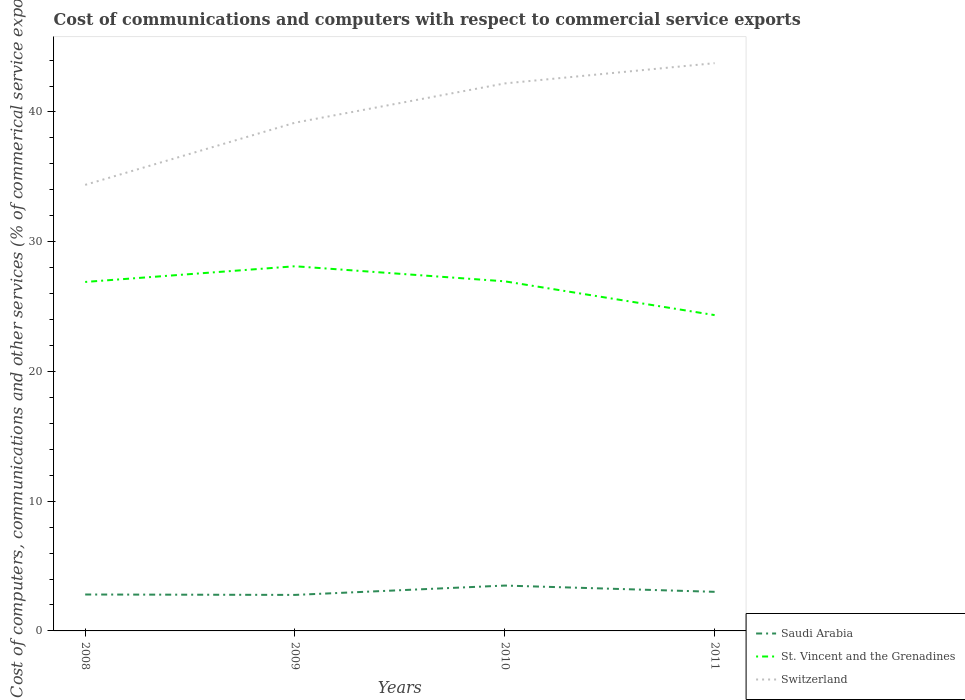How many different coloured lines are there?
Make the answer very short. 3. Does the line corresponding to St. Vincent and the Grenadines intersect with the line corresponding to Switzerland?
Ensure brevity in your answer.  No. Across all years, what is the maximum cost of communications and computers in St. Vincent and the Grenadines?
Your answer should be compact. 24.34. In which year was the cost of communications and computers in Switzerland maximum?
Your response must be concise. 2008. What is the total cost of communications and computers in St. Vincent and the Grenadines in the graph?
Offer a terse response. 3.77. What is the difference between the highest and the second highest cost of communications and computers in St. Vincent and the Grenadines?
Make the answer very short. 3.77. How many years are there in the graph?
Your answer should be very brief. 4. What is the difference between two consecutive major ticks on the Y-axis?
Your response must be concise. 10. Does the graph contain any zero values?
Provide a succinct answer. No. Where does the legend appear in the graph?
Keep it short and to the point. Bottom right. How many legend labels are there?
Your answer should be compact. 3. How are the legend labels stacked?
Provide a short and direct response. Vertical. What is the title of the graph?
Offer a terse response. Cost of communications and computers with respect to commercial service exports. Does "Mongolia" appear as one of the legend labels in the graph?
Your response must be concise. No. What is the label or title of the Y-axis?
Provide a short and direct response. Cost of computers, communications and other services (% of commerical service exports). What is the Cost of computers, communications and other services (% of commerical service exports) in Saudi Arabia in 2008?
Make the answer very short. 2.81. What is the Cost of computers, communications and other services (% of commerical service exports) of St. Vincent and the Grenadines in 2008?
Your answer should be very brief. 26.9. What is the Cost of computers, communications and other services (% of commerical service exports) in Switzerland in 2008?
Make the answer very short. 34.38. What is the Cost of computers, communications and other services (% of commerical service exports) in Saudi Arabia in 2009?
Your answer should be compact. 2.78. What is the Cost of computers, communications and other services (% of commerical service exports) of St. Vincent and the Grenadines in 2009?
Ensure brevity in your answer.  28.11. What is the Cost of computers, communications and other services (% of commerical service exports) in Switzerland in 2009?
Ensure brevity in your answer.  39.17. What is the Cost of computers, communications and other services (% of commerical service exports) of Saudi Arabia in 2010?
Ensure brevity in your answer.  3.5. What is the Cost of computers, communications and other services (% of commerical service exports) in St. Vincent and the Grenadines in 2010?
Ensure brevity in your answer.  26.95. What is the Cost of computers, communications and other services (% of commerical service exports) of Switzerland in 2010?
Provide a short and direct response. 42.2. What is the Cost of computers, communications and other services (% of commerical service exports) of Saudi Arabia in 2011?
Provide a succinct answer. 3.01. What is the Cost of computers, communications and other services (% of commerical service exports) in St. Vincent and the Grenadines in 2011?
Your response must be concise. 24.34. What is the Cost of computers, communications and other services (% of commerical service exports) in Switzerland in 2011?
Provide a succinct answer. 43.76. Across all years, what is the maximum Cost of computers, communications and other services (% of commerical service exports) of Saudi Arabia?
Offer a terse response. 3.5. Across all years, what is the maximum Cost of computers, communications and other services (% of commerical service exports) of St. Vincent and the Grenadines?
Your answer should be compact. 28.11. Across all years, what is the maximum Cost of computers, communications and other services (% of commerical service exports) of Switzerland?
Offer a terse response. 43.76. Across all years, what is the minimum Cost of computers, communications and other services (% of commerical service exports) in Saudi Arabia?
Provide a succinct answer. 2.78. Across all years, what is the minimum Cost of computers, communications and other services (% of commerical service exports) of St. Vincent and the Grenadines?
Your answer should be very brief. 24.34. Across all years, what is the minimum Cost of computers, communications and other services (% of commerical service exports) of Switzerland?
Ensure brevity in your answer.  34.38. What is the total Cost of computers, communications and other services (% of commerical service exports) in Saudi Arabia in the graph?
Offer a terse response. 12.09. What is the total Cost of computers, communications and other services (% of commerical service exports) of St. Vincent and the Grenadines in the graph?
Ensure brevity in your answer.  106.3. What is the total Cost of computers, communications and other services (% of commerical service exports) of Switzerland in the graph?
Provide a short and direct response. 159.52. What is the difference between the Cost of computers, communications and other services (% of commerical service exports) in Saudi Arabia in 2008 and that in 2009?
Provide a succinct answer. 0.03. What is the difference between the Cost of computers, communications and other services (% of commerical service exports) of St. Vincent and the Grenadines in 2008 and that in 2009?
Your answer should be very brief. -1.21. What is the difference between the Cost of computers, communications and other services (% of commerical service exports) of Switzerland in 2008 and that in 2009?
Offer a terse response. -4.79. What is the difference between the Cost of computers, communications and other services (% of commerical service exports) of Saudi Arabia in 2008 and that in 2010?
Ensure brevity in your answer.  -0.69. What is the difference between the Cost of computers, communications and other services (% of commerical service exports) of St. Vincent and the Grenadines in 2008 and that in 2010?
Keep it short and to the point. -0.05. What is the difference between the Cost of computers, communications and other services (% of commerical service exports) in Switzerland in 2008 and that in 2010?
Your answer should be very brief. -7.82. What is the difference between the Cost of computers, communications and other services (% of commerical service exports) of Saudi Arabia in 2008 and that in 2011?
Offer a very short reply. -0.21. What is the difference between the Cost of computers, communications and other services (% of commerical service exports) in St. Vincent and the Grenadines in 2008 and that in 2011?
Your answer should be very brief. 2.56. What is the difference between the Cost of computers, communications and other services (% of commerical service exports) of Switzerland in 2008 and that in 2011?
Keep it short and to the point. -9.38. What is the difference between the Cost of computers, communications and other services (% of commerical service exports) of Saudi Arabia in 2009 and that in 2010?
Keep it short and to the point. -0.72. What is the difference between the Cost of computers, communications and other services (% of commerical service exports) of St. Vincent and the Grenadines in 2009 and that in 2010?
Make the answer very short. 1.16. What is the difference between the Cost of computers, communications and other services (% of commerical service exports) of Switzerland in 2009 and that in 2010?
Provide a short and direct response. -3.03. What is the difference between the Cost of computers, communications and other services (% of commerical service exports) in Saudi Arabia in 2009 and that in 2011?
Offer a terse response. -0.24. What is the difference between the Cost of computers, communications and other services (% of commerical service exports) of St. Vincent and the Grenadines in 2009 and that in 2011?
Provide a short and direct response. 3.77. What is the difference between the Cost of computers, communications and other services (% of commerical service exports) of Switzerland in 2009 and that in 2011?
Offer a very short reply. -4.59. What is the difference between the Cost of computers, communications and other services (% of commerical service exports) in Saudi Arabia in 2010 and that in 2011?
Give a very brief answer. 0.48. What is the difference between the Cost of computers, communications and other services (% of commerical service exports) in St. Vincent and the Grenadines in 2010 and that in 2011?
Ensure brevity in your answer.  2.6. What is the difference between the Cost of computers, communications and other services (% of commerical service exports) in Switzerland in 2010 and that in 2011?
Offer a terse response. -1.56. What is the difference between the Cost of computers, communications and other services (% of commerical service exports) in Saudi Arabia in 2008 and the Cost of computers, communications and other services (% of commerical service exports) in St. Vincent and the Grenadines in 2009?
Offer a terse response. -25.3. What is the difference between the Cost of computers, communications and other services (% of commerical service exports) of Saudi Arabia in 2008 and the Cost of computers, communications and other services (% of commerical service exports) of Switzerland in 2009?
Make the answer very short. -36.37. What is the difference between the Cost of computers, communications and other services (% of commerical service exports) of St. Vincent and the Grenadines in 2008 and the Cost of computers, communications and other services (% of commerical service exports) of Switzerland in 2009?
Make the answer very short. -12.27. What is the difference between the Cost of computers, communications and other services (% of commerical service exports) of Saudi Arabia in 2008 and the Cost of computers, communications and other services (% of commerical service exports) of St. Vincent and the Grenadines in 2010?
Keep it short and to the point. -24.14. What is the difference between the Cost of computers, communications and other services (% of commerical service exports) of Saudi Arabia in 2008 and the Cost of computers, communications and other services (% of commerical service exports) of Switzerland in 2010?
Give a very brief answer. -39.39. What is the difference between the Cost of computers, communications and other services (% of commerical service exports) in St. Vincent and the Grenadines in 2008 and the Cost of computers, communications and other services (% of commerical service exports) in Switzerland in 2010?
Offer a very short reply. -15.3. What is the difference between the Cost of computers, communications and other services (% of commerical service exports) of Saudi Arabia in 2008 and the Cost of computers, communications and other services (% of commerical service exports) of St. Vincent and the Grenadines in 2011?
Offer a very short reply. -21.54. What is the difference between the Cost of computers, communications and other services (% of commerical service exports) of Saudi Arabia in 2008 and the Cost of computers, communications and other services (% of commerical service exports) of Switzerland in 2011?
Your response must be concise. -40.96. What is the difference between the Cost of computers, communications and other services (% of commerical service exports) of St. Vincent and the Grenadines in 2008 and the Cost of computers, communications and other services (% of commerical service exports) of Switzerland in 2011?
Provide a short and direct response. -16.86. What is the difference between the Cost of computers, communications and other services (% of commerical service exports) of Saudi Arabia in 2009 and the Cost of computers, communications and other services (% of commerical service exports) of St. Vincent and the Grenadines in 2010?
Make the answer very short. -24.17. What is the difference between the Cost of computers, communications and other services (% of commerical service exports) in Saudi Arabia in 2009 and the Cost of computers, communications and other services (% of commerical service exports) in Switzerland in 2010?
Provide a succinct answer. -39.42. What is the difference between the Cost of computers, communications and other services (% of commerical service exports) of St. Vincent and the Grenadines in 2009 and the Cost of computers, communications and other services (% of commerical service exports) of Switzerland in 2010?
Your response must be concise. -14.09. What is the difference between the Cost of computers, communications and other services (% of commerical service exports) in Saudi Arabia in 2009 and the Cost of computers, communications and other services (% of commerical service exports) in St. Vincent and the Grenadines in 2011?
Make the answer very short. -21.57. What is the difference between the Cost of computers, communications and other services (% of commerical service exports) in Saudi Arabia in 2009 and the Cost of computers, communications and other services (% of commerical service exports) in Switzerland in 2011?
Provide a short and direct response. -40.99. What is the difference between the Cost of computers, communications and other services (% of commerical service exports) in St. Vincent and the Grenadines in 2009 and the Cost of computers, communications and other services (% of commerical service exports) in Switzerland in 2011?
Give a very brief answer. -15.65. What is the difference between the Cost of computers, communications and other services (% of commerical service exports) in Saudi Arabia in 2010 and the Cost of computers, communications and other services (% of commerical service exports) in St. Vincent and the Grenadines in 2011?
Keep it short and to the point. -20.85. What is the difference between the Cost of computers, communications and other services (% of commerical service exports) in Saudi Arabia in 2010 and the Cost of computers, communications and other services (% of commerical service exports) in Switzerland in 2011?
Make the answer very short. -40.27. What is the difference between the Cost of computers, communications and other services (% of commerical service exports) in St. Vincent and the Grenadines in 2010 and the Cost of computers, communications and other services (% of commerical service exports) in Switzerland in 2011?
Provide a short and direct response. -16.82. What is the average Cost of computers, communications and other services (% of commerical service exports) of Saudi Arabia per year?
Provide a short and direct response. 3.02. What is the average Cost of computers, communications and other services (% of commerical service exports) in St. Vincent and the Grenadines per year?
Provide a short and direct response. 26.57. What is the average Cost of computers, communications and other services (% of commerical service exports) of Switzerland per year?
Ensure brevity in your answer.  39.88. In the year 2008, what is the difference between the Cost of computers, communications and other services (% of commerical service exports) in Saudi Arabia and Cost of computers, communications and other services (% of commerical service exports) in St. Vincent and the Grenadines?
Your response must be concise. -24.09. In the year 2008, what is the difference between the Cost of computers, communications and other services (% of commerical service exports) of Saudi Arabia and Cost of computers, communications and other services (% of commerical service exports) of Switzerland?
Your response must be concise. -31.57. In the year 2008, what is the difference between the Cost of computers, communications and other services (% of commerical service exports) of St. Vincent and the Grenadines and Cost of computers, communications and other services (% of commerical service exports) of Switzerland?
Offer a terse response. -7.48. In the year 2009, what is the difference between the Cost of computers, communications and other services (% of commerical service exports) in Saudi Arabia and Cost of computers, communications and other services (% of commerical service exports) in St. Vincent and the Grenadines?
Your answer should be compact. -25.33. In the year 2009, what is the difference between the Cost of computers, communications and other services (% of commerical service exports) in Saudi Arabia and Cost of computers, communications and other services (% of commerical service exports) in Switzerland?
Keep it short and to the point. -36.4. In the year 2009, what is the difference between the Cost of computers, communications and other services (% of commerical service exports) in St. Vincent and the Grenadines and Cost of computers, communications and other services (% of commerical service exports) in Switzerland?
Your answer should be compact. -11.07. In the year 2010, what is the difference between the Cost of computers, communications and other services (% of commerical service exports) of Saudi Arabia and Cost of computers, communications and other services (% of commerical service exports) of St. Vincent and the Grenadines?
Offer a very short reply. -23.45. In the year 2010, what is the difference between the Cost of computers, communications and other services (% of commerical service exports) of Saudi Arabia and Cost of computers, communications and other services (% of commerical service exports) of Switzerland?
Keep it short and to the point. -38.7. In the year 2010, what is the difference between the Cost of computers, communications and other services (% of commerical service exports) in St. Vincent and the Grenadines and Cost of computers, communications and other services (% of commerical service exports) in Switzerland?
Give a very brief answer. -15.25. In the year 2011, what is the difference between the Cost of computers, communications and other services (% of commerical service exports) of Saudi Arabia and Cost of computers, communications and other services (% of commerical service exports) of St. Vincent and the Grenadines?
Your answer should be very brief. -21.33. In the year 2011, what is the difference between the Cost of computers, communications and other services (% of commerical service exports) in Saudi Arabia and Cost of computers, communications and other services (% of commerical service exports) in Switzerland?
Offer a very short reply. -40.75. In the year 2011, what is the difference between the Cost of computers, communications and other services (% of commerical service exports) in St. Vincent and the Grenadines and Cost of computers, communications and other services (% of commerical service exports) in Switzerland?
Provide a short and direct response. -19.42. What is the ratio of the Cost of computers, communications and other services (% of commerical service exports) in Saudi Arabia in 2008 to that in 2009?
Make the answer very short. 1.01. What is the ratio of the Cost of computers, communications and other services (% of commerical service exports) of Switzerland in 2008 to that in 2009?
Your answer should be compact. 0.88. What is the ratio of the Cost of computers, communications and other services (% of commerical service exports) of Saudi Arabia in 2008 to that in 2010?
Provide a succinct answer. 0.8. What is the ratio of the Cost of computers, communications and other services (% of commerical service exports) of Switzerland in 2008 to that in 2010?
Offer a terse response. 0.81. What is the ratio of the Cost of computers, communications and other services (% of commerical service exports) in Saudi Arabia in 2008 to that in 2011?
Your answer should be compact. 0.93. What is the ratio of the Cost of computers, communications and other services (% of commerical service exports) in St. Vincent and the Grenadines in 2008 to that in 2011?
Your response must be concise. 1.1. What is the ratio of the Cost of computers, communications and other services (% of commerical service exports) in Switzerland in 2008 to that in 2011?
Ensure brevity in your answer.  0.79. What is the ratio of the Cost of computers, communications and other services (% of commerical service exports) in Saudi Arabia in 2009 to that in 2010?
Your answer should be very brief. 0.79. What is the ratio of the Cost of computers, communications and other services (% of commerical service exports) of St. Vincent and the Grenadines in 2009 to that in 2010?
Ensure brevity in your answer.  1.04. What is the ratio of the Cost of computers, communications and other services (% of commerical service exports) of Switzerland in 2009 to that in 2010?
Give a very brief answer. 0.93. What is the ratio of the Cost of computers, communications and other services (% of commerical service exports) of Saudi Arabia in 2009 to that in 2011?
Keep it short and to the point. 0.92. What is the ratio of the Cost of computers, communications and other services (% of commerical service exports) in St. Vincent and the Grenadines in 2009 to that in 2011?
Your response must be concise. 1.15. What is the ratio of the Cost of computers, communications and other services (% of commerical service exports) of Switzerland in 2009 to that in 2011?
Your response must be concise. 0.9. What is the ratio of the Cost of computers, communications and other services (% of commerical service exports) in Saudi Arabia in 2010 to that in 2011?
Offer a very short reply. 1.16. What is the ratio of the Cost of computers, communications and other services (% of commerical service exports) of St. Vincent and the Grenadines in 2010 to that in 2011?
Offer a terse response. 1.11. What is the difference between the highest and the second highest Cost of computers, communications and other services (% of commerical service exports) of Saudi Arabia?
Keep it short and to the point. 0.48. What is the difference between the highest and the second highest Cost of computers, communications and other services (% of commerical service exports) in St. Vincent and the Grenadines?
Ensure brevity in your answer.  1.16. What is the difference between the highest and the second highest Cost of computers, communications and other services (% of commerical service exports) of Switzerland?
Your answer should be very brief. 1.56. What is the difference between the highest and the lowest Cost of computers, communications and other services (% of commerical service exports) in Saudi Arabia?
Make the answer very short. 0.72. What is the difference between the highest and the lowest Cost of computers, communications and other services (% of commerical service exports) of St. Vincent and the Grenadines?
Ensure brevity in your answer.  3.77. What is the difference between the highest and the lowest Cost of computers, communications and other services (% of commerical service exports) in Switzerland?
Provide a succinct answer. 9.38. 